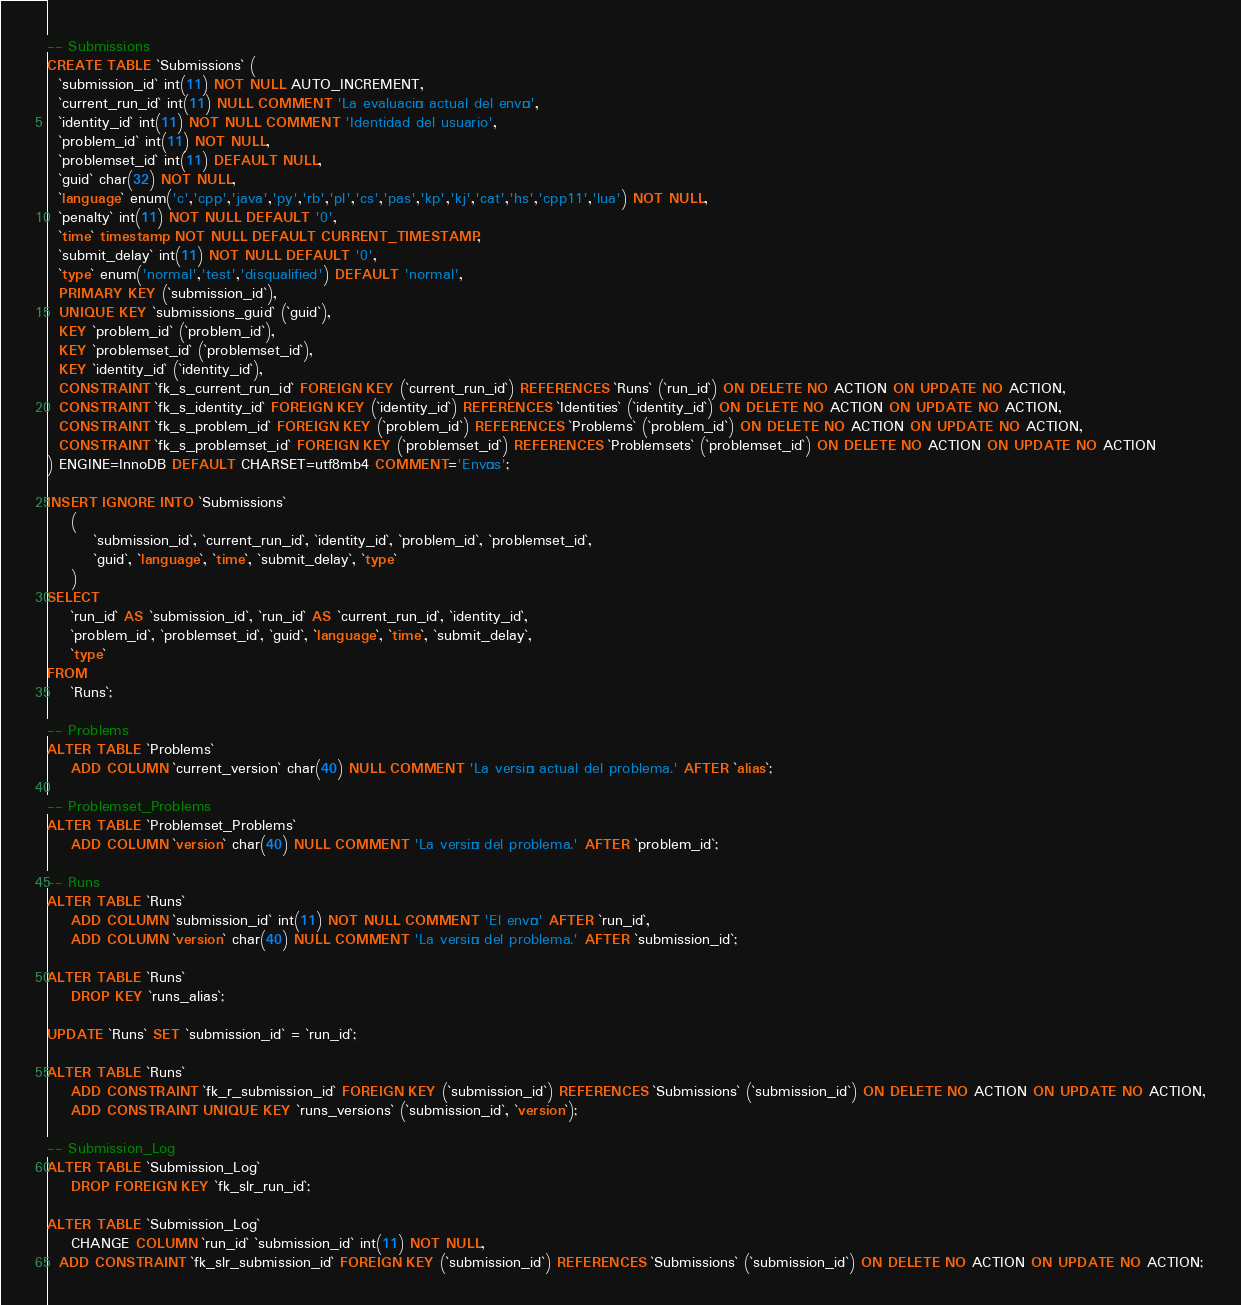<code> <loc_0><loc_0><loc_500><loc_500><_SQL_>-- Submissions
CREATE TABLE `Submissions` (
  `submission_id` int(11) NOT NULL AUTO_INCREMENT,
  `current_run_id` int(11) NULL COMMENT 'La evaluación actual del envío',
  `identity_id` int(11) NOT NULL COMMENT 'Identidad del usuario',
  `problem_id` int(11) NOT NULL,
  `problemset_id` int(11) DEFAULT NULL,
  `guid` char(32) NOT NULL,
  `language` enum('c','cpp','java','py','rb','pl','cs','pas','kp','kj','cat','hs','cpp11','lua') NOT NULL,
  `penalty` int(11) NOT NULL DEFAULT '0',
  `time` timestamp NOT NULL DEFAULT CURRENT_TIMESTAMP,
  `submit_delay` int(11) NOT NULL DEFAULT '0',
  `type` enum('normal','test','disqualified') DEFAULT 'normal',
  PRIMARY KEY (`submission_id`),
  UNIQUE KEY `submissions_guid` (`guid`),
  KEY `problem_id` (`problem_id`),
  KEY `problemset_id` (`problemset_id`),
  KEY `identity_id` (`identity_id`),
  CONSTRAINT `fk_s_current_run_id` FOREIGN KEY (`current_run_id`) REFERENCES `Runs` (`run_id`) ON DELETE NO ACTION ON UPDATE NO ACTION,
  CONSTRAINT `fk_s_identity_id` FOREIGN KEY (`identity_id`) REFERENCES `Identities` (`identity_id`) ON DELETE NO ACTION ON UPDATE NO ACTION,
  CONSTRAINT `fk_s_problem_id` FOREIGN KEY (`problem_id`) REFERENCES `Problems` (`problem_id`) ON DELETE NO ACTION ON UPDATE NO ACTION,
  CONSTRAINT `fk_s_problemset_id` FOREIGN KEY (`problemset_id`) REFERENCES `Problemsets` (`problemset_id`) ON DELETE NO ACTION ON UPDATE NO ACTION
) ENGINE=InnoDB DEFAULT CHARSET=utf8mb4 COMMENT='Envíos';

INSERT IGNORE INTO `Submissions`
	(
		`submission_id`, `current_run_id`, `identity_id`, `problem_id`, `problemset_id`,
		`guid`, `language`, `time`, `submit_delay`, `type`
	)
SELECT
	`run_id` AS `submission_id`, `run_id` AS `current_run_id`, `identity_id`,
	`problem_id`, `problemset_id`, `guid`, `language`, `time`, `submit_delay`,
	`type`
FROM
	`Runs`;

-- Problems
ALTER TABLE `Problems`
	ADD COLUMN `current_version` char(40) NULL COMMENT 'La versión actual del problema.' AFTER `alias`;

-- Problemset_Problems
ALTER TABLE `Problemset_Problems`
	ADD COLUMN `version` char(40) NULL COMMENT 'La versión del problema.' AFTER `problem_id`;

-- Runs
ALTER TABLE `Runs`
	ADD COLUMN `submission_id` int(11) NOT NULL COMMENT 'El envío' AFTER `run_id`,
	ADD COLUMN `version` char(40) NULL COMMENT 'La versión del problema.' AFTER `submission_id`;

ALTER TABLE `Runs`
	DROP KEY `runs_alias`;

UPDATE `Runs` SET `submission_id` = `run_id`;

ALTER TABLE `Runs`
	ADD CONSTRAINT `fk_r_submission_id` FOREIGN KEY (`submission_id`) REFERENCES `Submissions` (`submission_id`) ON DELETE NO ACTION ON UPDATE NO ACTION,
	ADD CONSTRAINT UNIQUE KEY `runs_versions` (`submission_id`, `version`);

-- Submission_Log
ALTER TABLE `Submission_Log`
	DROP FOREIGN KEY `fk_slr_run_id`;

ALTER TABLE `Submission_Log`
	CHANGE COLUMN `run_id` `submission_id` int(11) NOT NULL,
  ADD CONSTRAINT `fk_slr_submission_id` FOREIGN KEY (`submission_id`) REFERENCES `Submissions` (`submission_id`) ON DELETE NO ACTION ON UPDATE NO ACTION;
</code> 